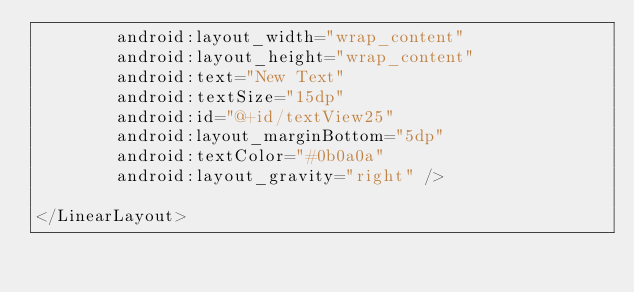<code> <loc_0><loc_0><loc_500><loc_500><_XML_>        android:layout_width="wrap_content"
        android:layout_height="wrap_content"
        android:text="New Text"
        android:textSize="15dp"
        android:id="@+id/textView25"
        android:layout_marginBottom="5dp"
        android:textColor="#0b0a0a"
        android:layout_gravity="right" />

</LinearLayout></code> 